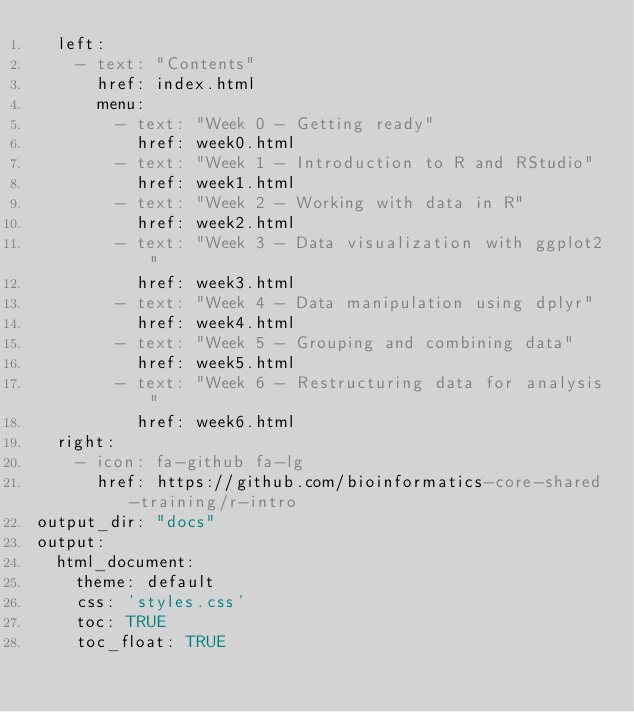Convert code to text. <code><loc_0><loc_0><loc_500><loc_500><_YAML_>  left:
    - text: "Contents"
      href: index.html
      menu:
        - text: "Week 0 - Getting ready"
          href: week0.html
        - text: "Week 1 - Introduction to R and RStudio"
          href: week1.html
        - text: "Week 2 - Working with data in R"
          href: week2.html
        - text: "Week 3 - Data visualization with ggplot2"
          href: week3.html
        - text: "Week 4 - Data manipulation using dplyr"
          href: week4.html
        - text: "Week 5 - Grouping and combining data"
          href: week5.html
        - text: "Week 6 - Restructuring data for analysis"
          href: week6.html
  right:
    - icon: fa-github fa-lg
      href: https://github.com/bioinformatics-core-shared-training/r-intro
output_dir: "docs"
output:
  html_document:
    theme: default
    css: 'styles.css'
    toc: TRUE
    toc_float: TRUE

</code> 